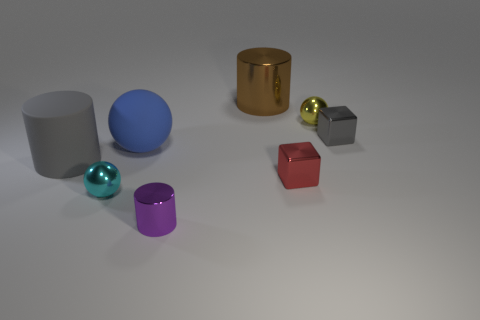There is a gray thing left of the cyan metallic ball; how big is it?
Give a very brief answer. Large. There is a small shiny ball left of the purple cylinder; how many large gray cylinders are in front of it?
Your response must be concise. 0. There is a shiny object that is to the left of the big ball; is its shape the same as the gray object left of the brown thing?
Keep it short and to the point. No. How many tiny things are both left of the large rubber ball and on the right side of the red shiny object?
Give a very brief answer. 0. Are there any small metallic balls that have the same color as the tiny metal cylinder?
Your answer should be very brief. No. What is the shape of the matte object that is the same size as the gray rubber cylinder?
Provide a succinct answer. Sphere. Are there any yellow things right of the small yellow shiny ball?
Your answer should be very brief. No. Do the tiny red thing that is on the left side of the tiny gray block and the large thing that is to the left of the cyan metal ball have the same material?
Make the answer very short. No. What number of purple things have the same size as the brown thing?
Your answer should be very brief. 0. What shape is the shiny object that is the same color as the matte cylinder?
Ensure brevity in your answer.  Cube. 